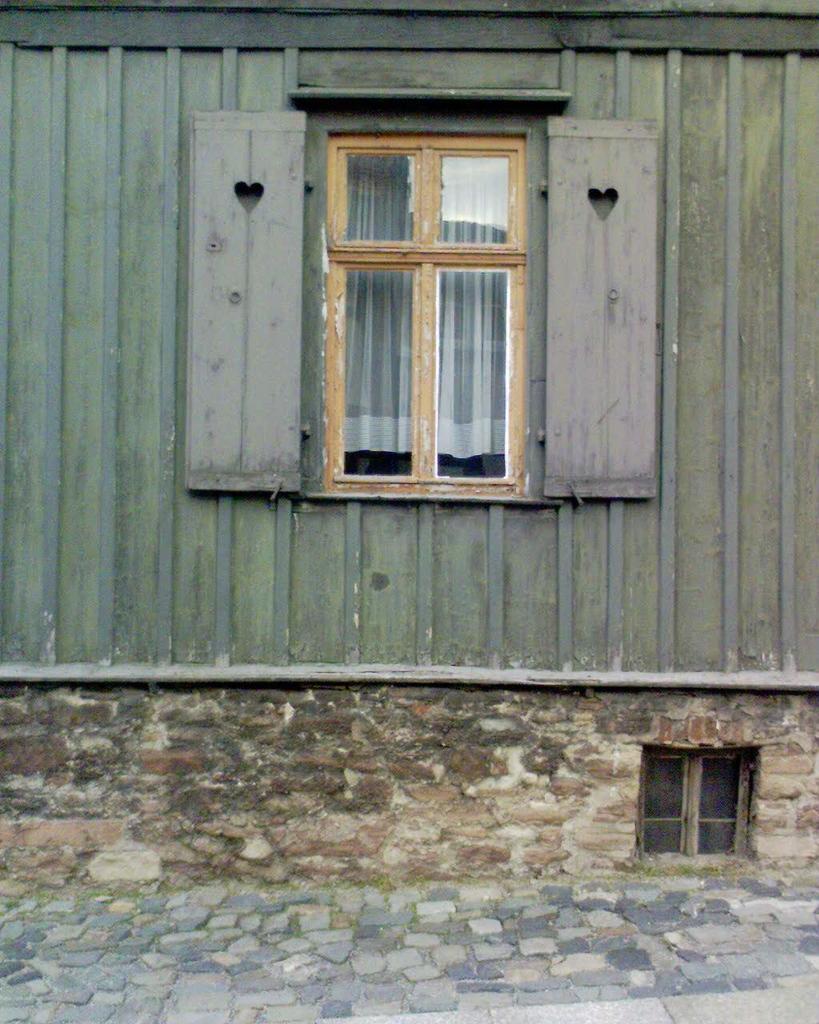In one or two sentences, can you explain what this image depicts? In this image there is a wall and on the top of the wall there is a tin and there is a window. 